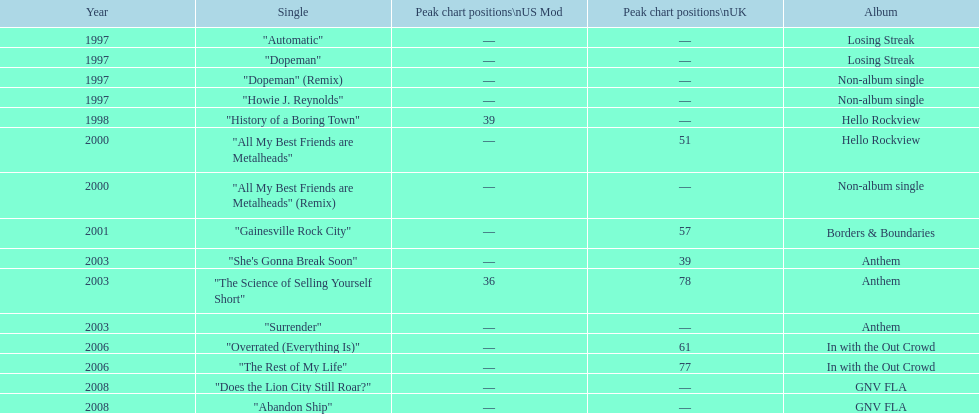What was the average chart position of their singles in the uk? 60.5. 